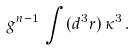<formula> <loc_0><loc_0><loc_500><loc_500>g ^ { n - 1 } \, \int ( d ^ { 3 } { r } ) \, \kappa ^ { 3 } \, .</formula> 